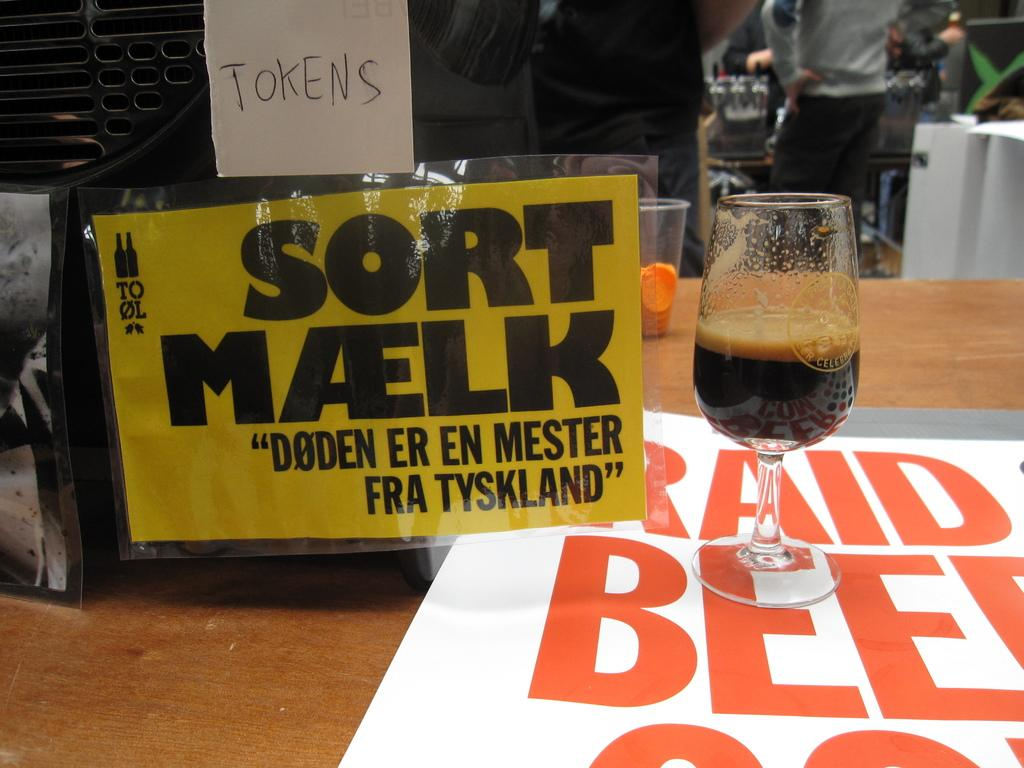What is in the glass that is visible in the image? There is a glass with liquid in the image. Where is the glass located in the image? The glass is on a table in the image. What is on the wall in the image? There is a poster with writing on it in the image. Where is the poster located in the image? The poster is on a wall in the image. What is the person in the image doing? The person is standing in front of the table in the image. What is the person standing on in the image? The person is standing on the floor in the image. What song is the person singing in the image? There is no indication in the image that the person is singing, and therefore no song can be identified. Can you see a trail leading to the table in the image? There is no trail visible in the image. 